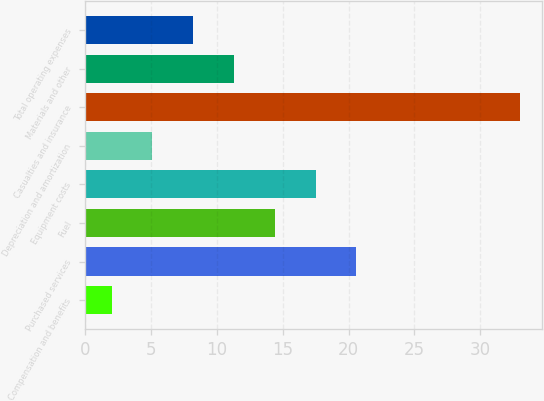Convert chart to OTSL. <chart><loc_0><loc_0><loc_500><loc_500><bar_chart><fcel>Compensation and benefits<fcel>Purchased services<fcel>Fuel<fcel>Equipment costs<fcel>Depreciation and amortization<fcel>Casualties and insurance<fcel>Materials and other<fcel>Total operating expenses<nl><fcel>2<fcel>20.6<fcel>14.4<fcel>17.5<fcel>5.1<fcel>33<fcel>11.3<fcel>8.2<nl></chart> 